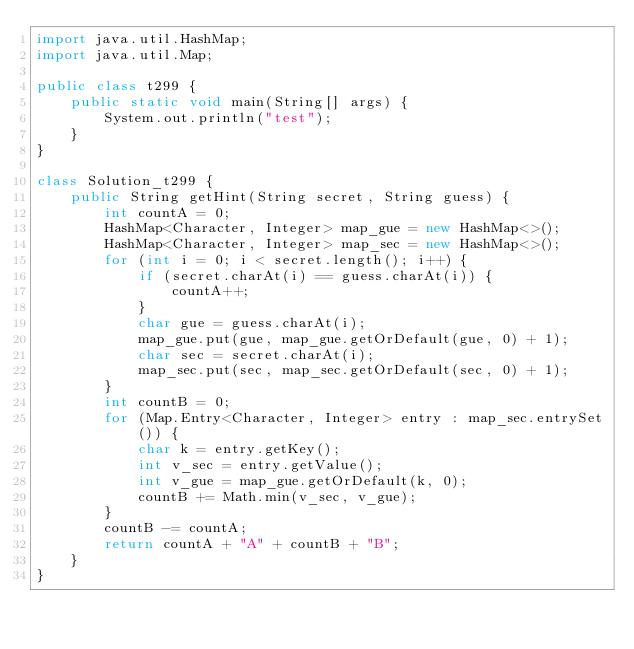<code> <loc_0><loc_0><loc_500><loc_500><_Java_>import java.util.HashMap;
import java.util.Map;

public class t299 {
    public static void main(String[] args) {
        System.out.println("test");
    }
}

class Solution_t299 {
    public String getHint(String secret, String guess) {
        int countA = 0;
        HashMap<Character, Integer> map_gue = new HashMap<>();
        HashMap<Character, Integer> map_sec = new HashMap<>();
        for (int i = 0; i < secret.length(); i++) {
            if (secret.charAt(i) == guess.charAt(i)) {
                countA++;
            }
            char gue = guess.charAt(i);
            map_gue.put(gue, map_gue.getOrDefault(gue, 0) + 1);
            char sec = secret.charAt(i);
            map_sec.put(sec, map_sec.getOrDefault(sec, 0) + 1);
        }
        int countB = 0;
        for (Map.Entry<Character, Integer> entry : map_sec.entrySet()) {
            char k = entry.getKey();
            int v_sec = entry.getValue();
            int v_gue = map_gue.getOrDefault(k, 0);
            countB += Math.min(v_sec, v_gue);
        }
        countB -= countA;
        return countA + "A" + countB + "B";
    }
}</code> 